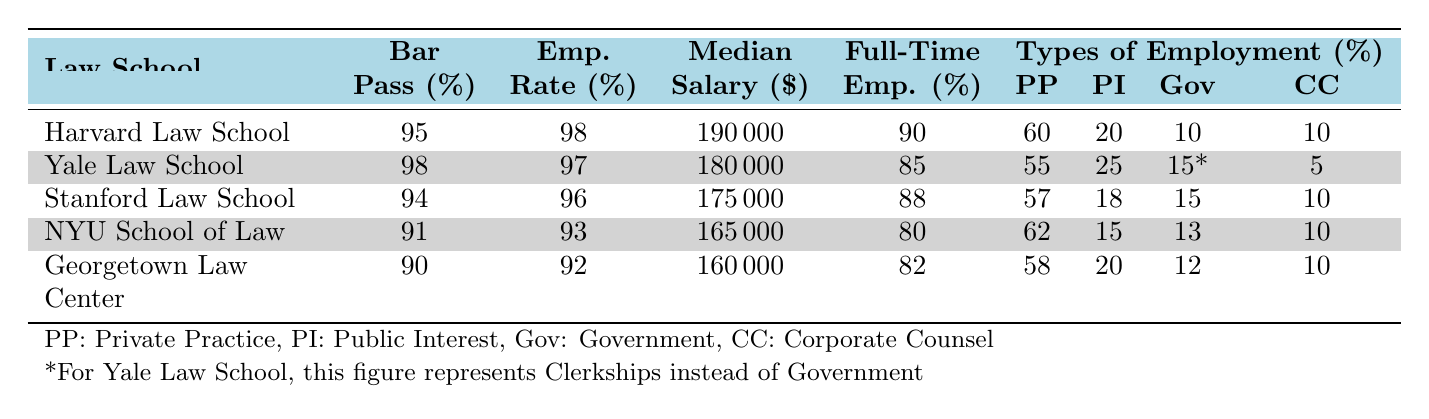What is the Bar Passage Rate for Yale Law School? The table shows the Bar Passage Rate for Yale Law School as 98%.
Answer: 98 Which Law School has the highest Median Salary? By examining the Median Salary column, Harvard Law School has the highest Median Salary at $190,000.
Answer: Harvard Law School What is the Full-Time Employment Rate for New York University School of Law? The Full-Time Employment Rate for New York University School of Law is 80%, as stated in the table.
Answer: 80 How many Law Schools have an Employment Rate of 96% or higher? The table shows that Harvard Law School (98%), Yale Law School (97%), Stanford Law School (96%) are the only schools with an Employment Rate of 96% or higher; thus, there are three Law Schools.
Answer: 3 What is the difference between the Median Salary of Harvard Law School and the Median Salary of Georgetown University Law Center? The Median Salary of Harvard Law School is $190,000 and Georgetown University Law Center is $160,000. The difference is $190,000 - $160,000 = $30,000.
Answer: $30,000 Is it true that Stanford Law School has a higher Full-Time Employment Rate than New York University School of Law? Looking at the Full-Time Employment Rate, Stanford Law School has 88% while NYU School of Law has 80%. Since 88% is greater than 80%, the statement is true.
Answer: Yes Which types of employment have the highest and lowest percentages for Georgetown University Law Center? For Georgetown University Law Center, the highest percentage is Private Practice (58%), and the lowest is Corporate Counsel (10%).
Answer: PP: 58%, CC: 10% Calculate the average Bar Passage Rate of all the Law Schools listed in the table. The Bar Passage Rates are 95%, 98%, 94%, 91%, and 90%. The sum is 95 + 98 + 94 + 91 + 90 = 468. There are 5 Law Schools, so the average Bar Passage Rate is 468 / 5 = 93.6%.
Answer: 93.6% What percentage of Yale Law School graduates go into Public Interest? According to the table, 25% of Yale Law School graduates go into Public Interest.
Answer: 25% Does New York University School of Law have a higher percentage of graduates in Private Practice than Georgetown University Law Center? New York University School of Law has 62% in Private Practice, while Georgetown University Law Center has 58%. Since 62% is greater than 58%, the statement is true.
Answer: Yes 